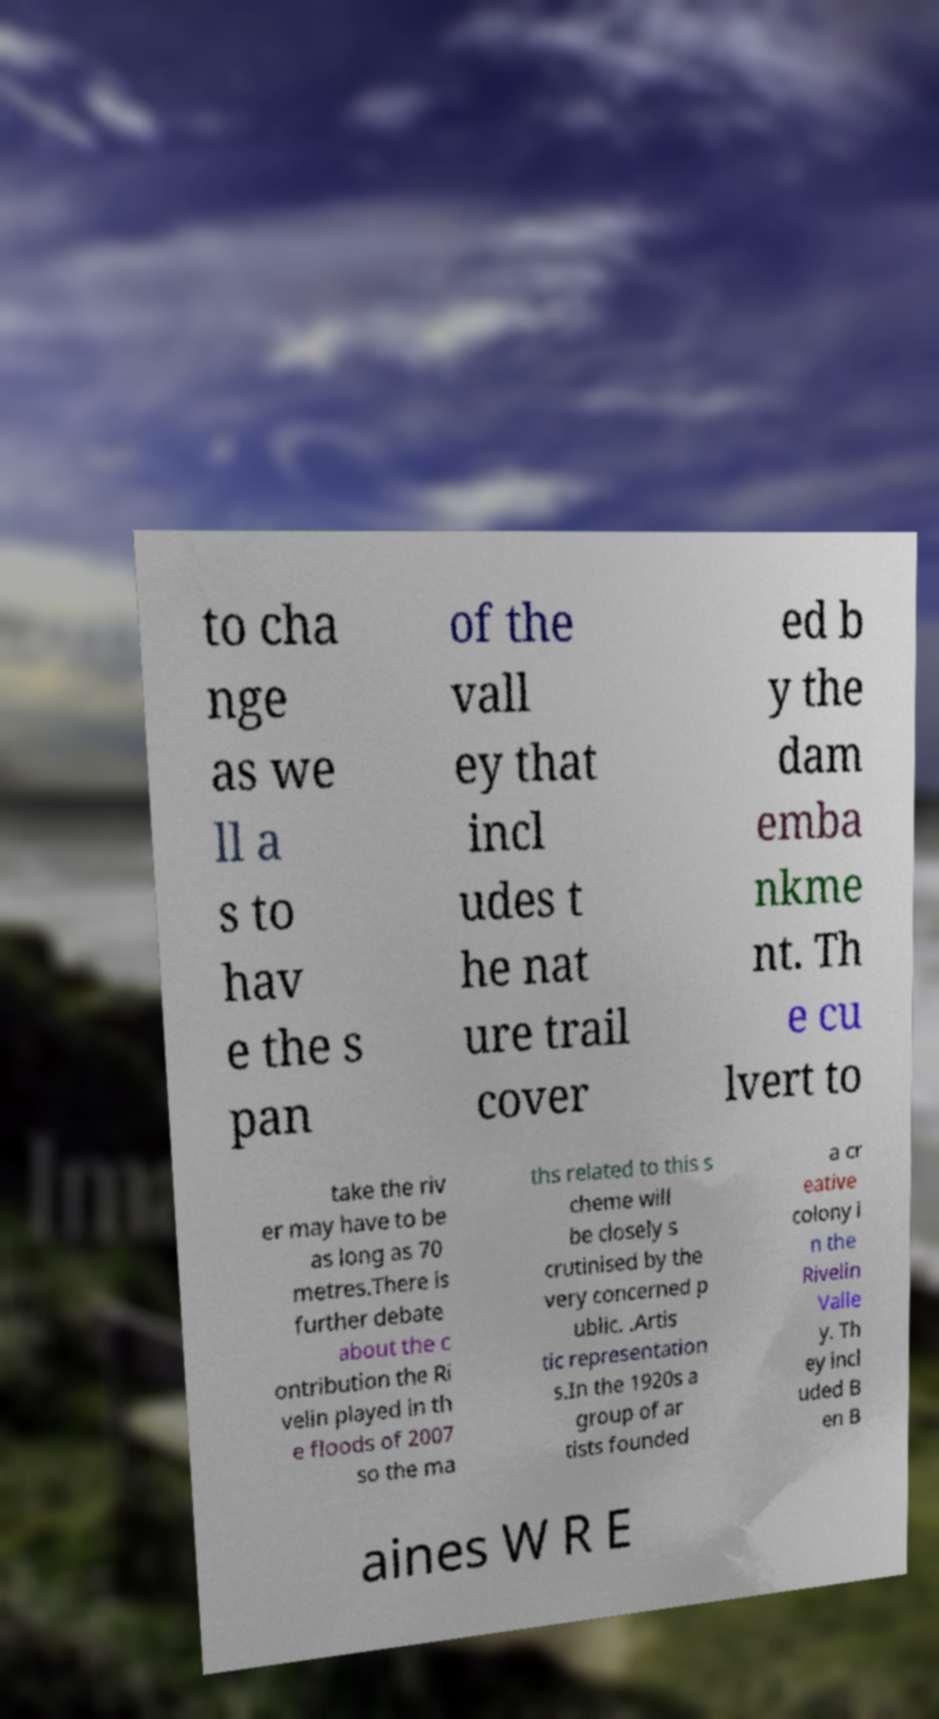Could you assist in decoding the text presented in this image and type it out clearly? to cha nge as we ll a s to hav e the s pan of the vall ey that incl udes t he nat ure trail cover ed b y the dam emba nkme nt. Th e cu lvert to take the riv er may have to be as long as 70 metres.There is further debate about the c ontribution the Ri velin played in th e floods of 2007 so the ma ths related to this s cheme will be closely s crutinised by the very concerned p ublic. .Artis tic representation s.In the 1920s a group of ar tists founded a cr eative colony i n the Rivelin Valle y. Th ey incl uded B en B aines W R E 